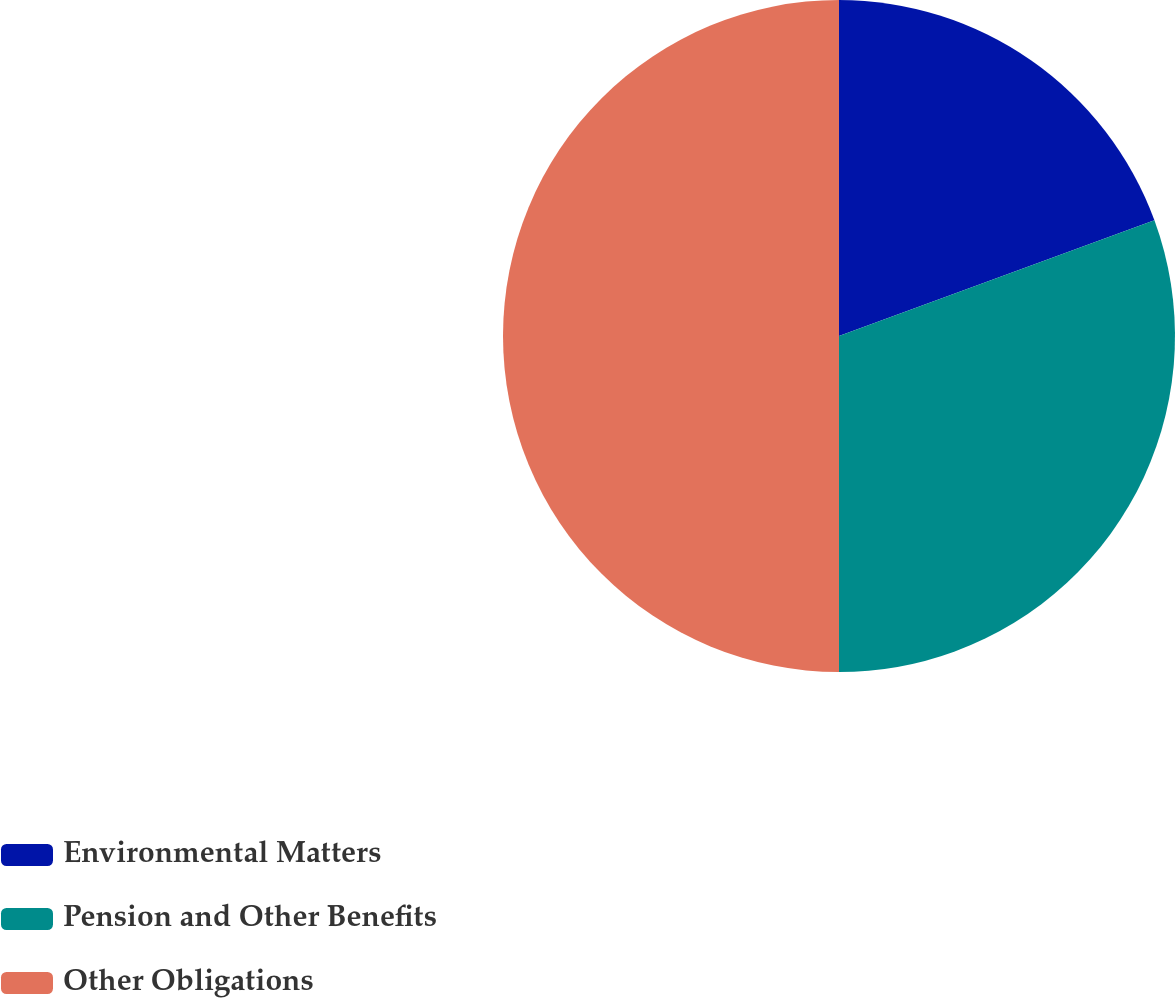<chart> <loc_0><loc_0><loc_500><loc_500><pie_chart><fcel>Environmental Matters<fcel>Pension and Other Benefits<fcel>Other Obligations<nl><fcel>19.4%<fcel>30.6%<fcel>50.0%<nl></chart> 